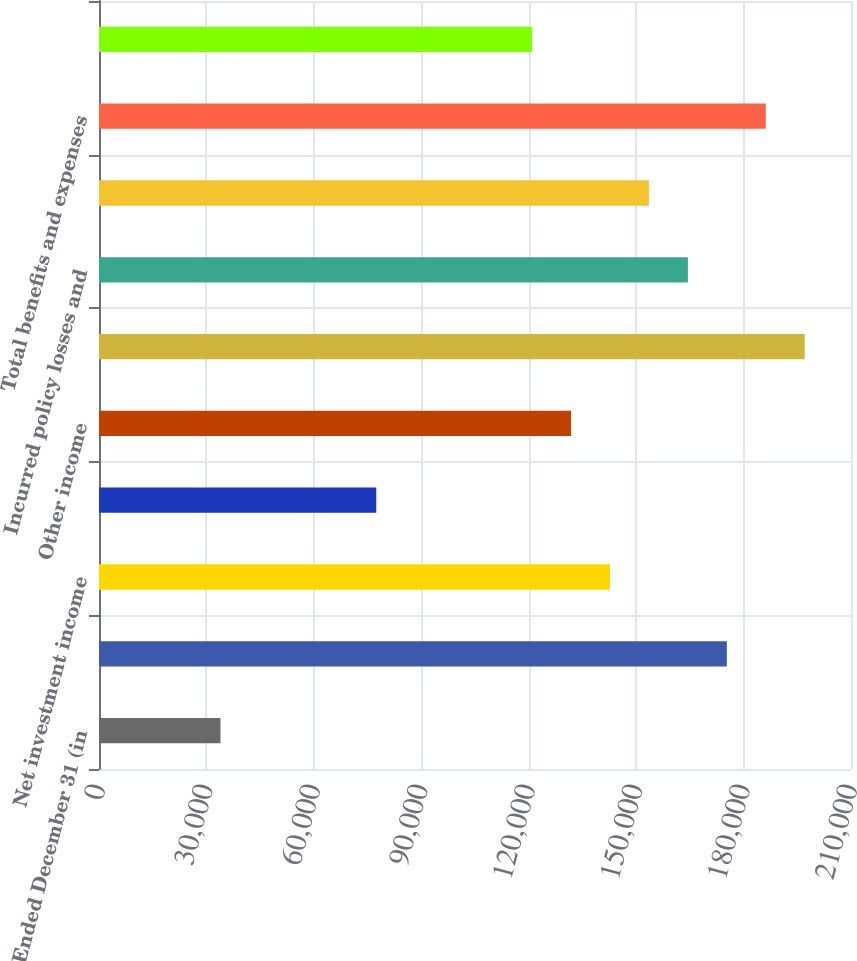Convert chart to OTSL. <chart><loc_0><loc_0><loc_500><loc_500><bar_chart><fcel>Years Ended December 31 (in<fcel>Premiums and other<fcel>Net investment income<fcel>Net realized capital gains<fcel>Other income<fcel>Total revenues<fcel>Incurred policy losses and<fcel>Insurance acquisition and<fcel>Total benefits and expenses<fcel>Income before income taxes<nl><fcel>33920.8<fcel>175330<fcel>142697<fcel>77431.2<fcel>131819<fcel>197085<fcel>164452<fcel>153574<fcel>186207<fcel>120942<nl></chart> 